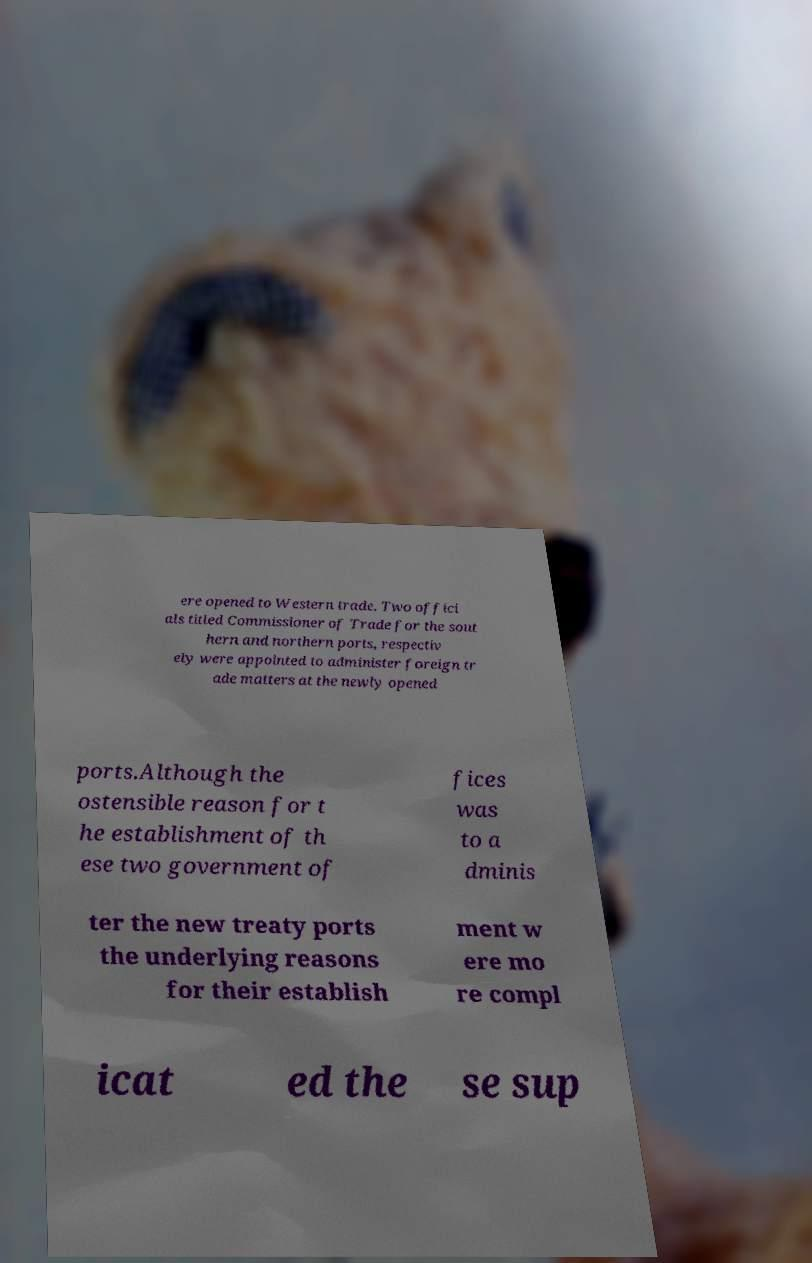Can you accurately transcribe the text from the provided image for me? ere opened to Western trade. Two offici als titled Commissioner of Trade for the sout hern and northern ports, respectiv ely were appointed to administer foreign tr ade matters at the newly opened ports.Although the ostensible reason for t he establishment of th ese two government of fices was to a dminis ter the new treaty ports the underlying reasons for their establish ment w ere mo re compl icat ed the se sup 